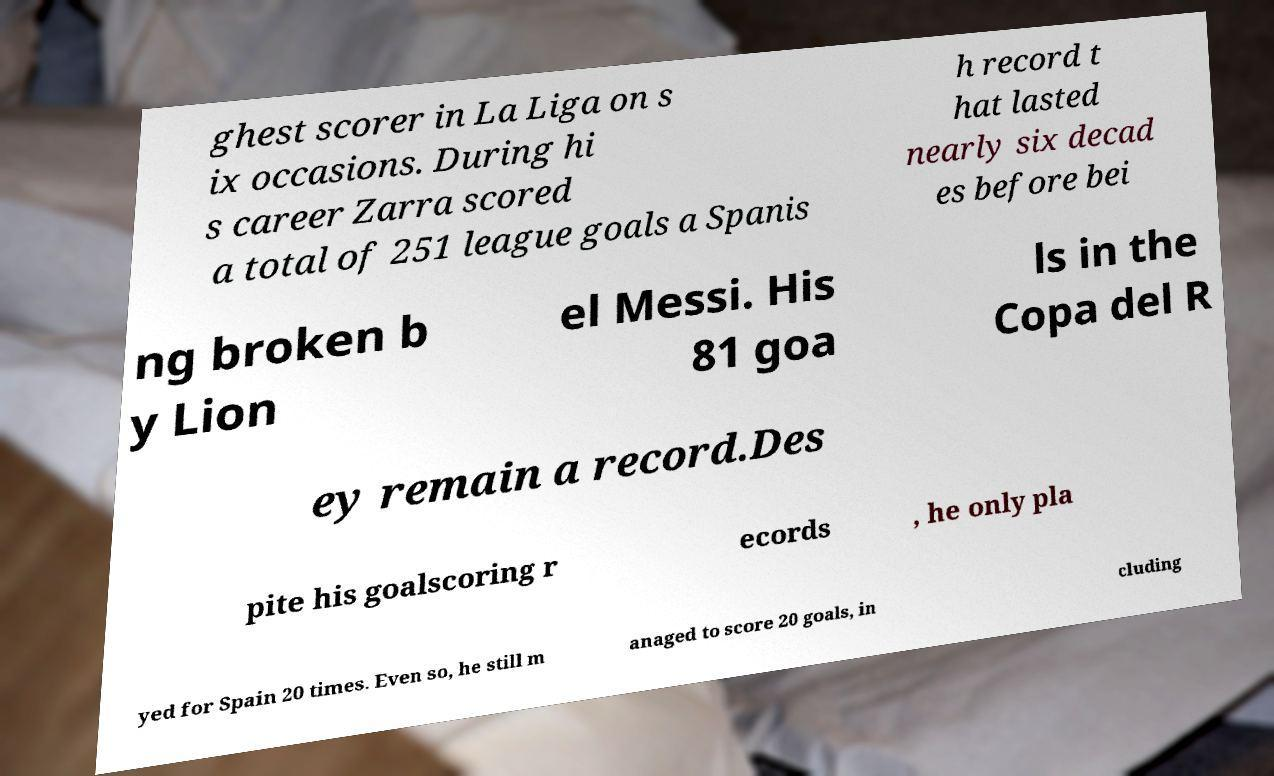Could you extract and type out the text from this image? ghest scorer in La Liga on s ix occasions. During hi s career Zarra scored a total of 251 league goals a Spanis h record t hat lasted nearly six decad es before bei ng broken b y Lion el Messi. His 81 goa ls in the Copa del R ey remain a record.Des pite his goalscoring r ecords , he only pla yed for Spain 20 times. Even so, he still m anaged to score 20 goals, in cluding 